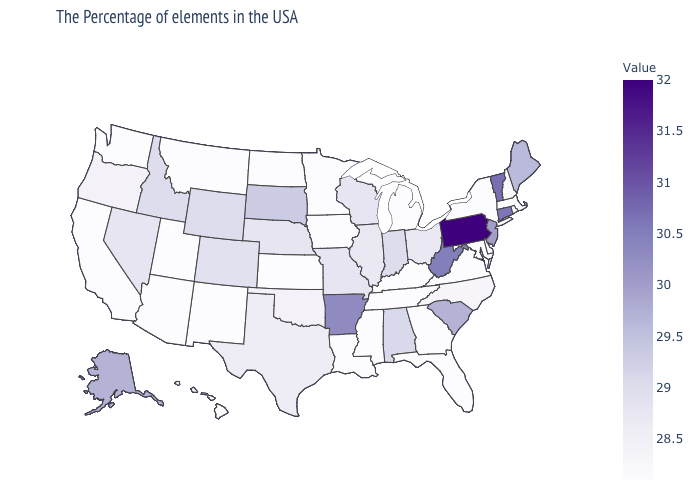Is the legend a continuous bar?
Quick response, please. Yes. Does Texas have a higher value than Massachusetts?
Be succinct. Yes. Does Pennsylvania have the highest value in the USA?
Be succinct. Yes. 